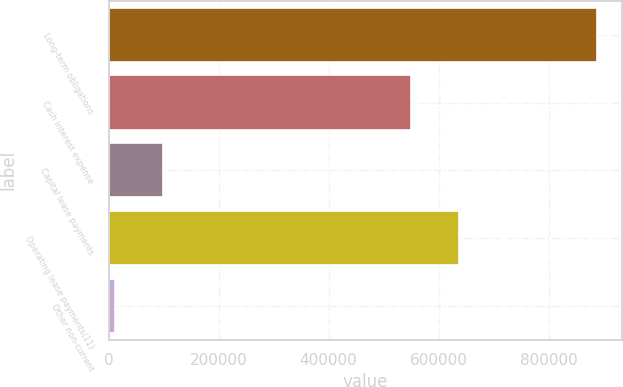<chart> <loc_0><loc_0><loc_500><loc_500><bar_chart><fcel>Long-term obligations<fcel>Cash interest expense<fcel>Capital lease payments<fcel>Operating lease payments(11)<fcel>Other non-current<nl><fcel>888810<fcel>550000<fcel>98854.8<fcel>637773<fcel>11082<nl></chart> 